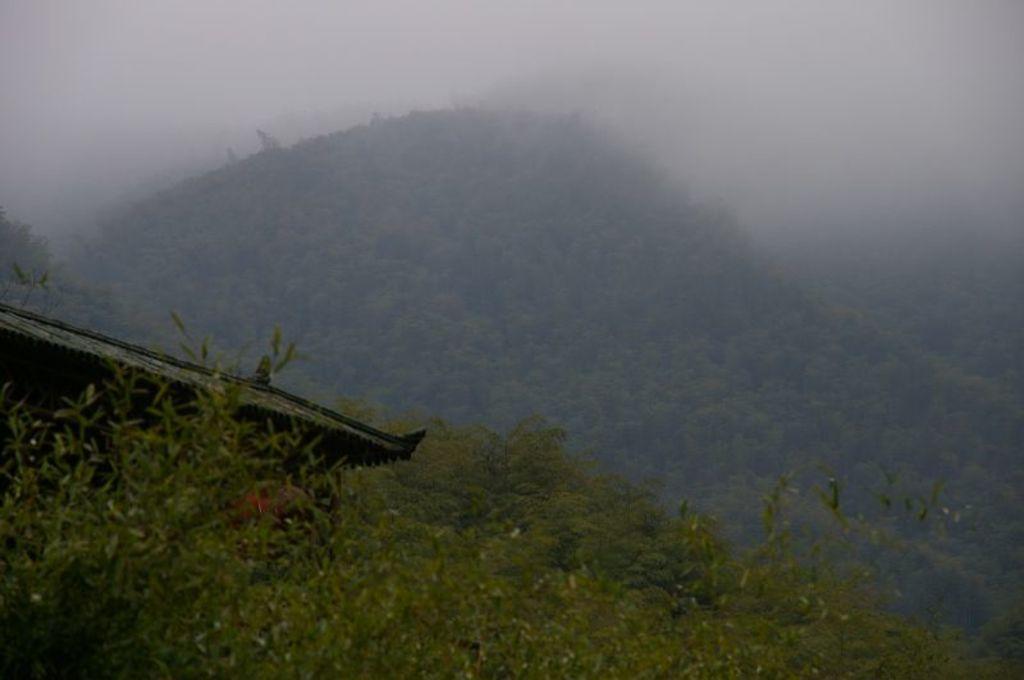Please provide a concise description of this image. In this image I can see mountains,trees and a house. The sky is in white and blue color. 